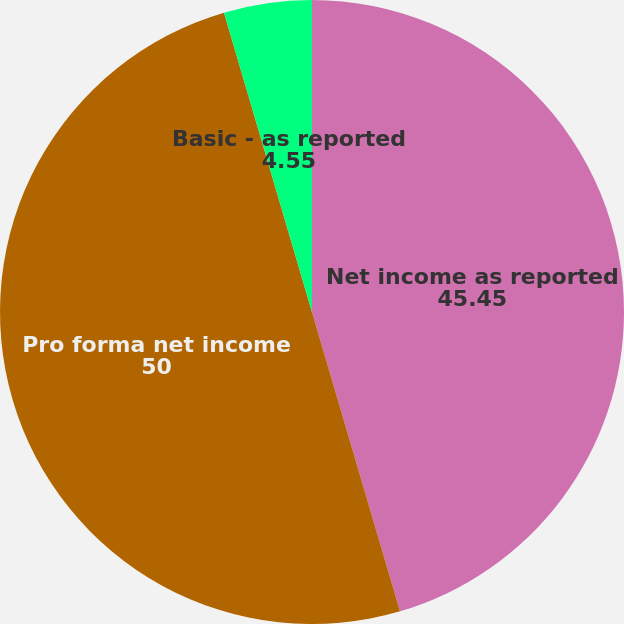Convert chart to OTSL. <chart><loc_0><loc_0><loc_500><loc_500><pie_chart><fcel>Net income as reported<fcel>Pro forma net income<fcel>Basic - as reported<fcel>Diluted - as reported<nl><fcel>45.45%<fcel>50.0%<fcel>4.55%<fcel>0.0%<nl></chart> 